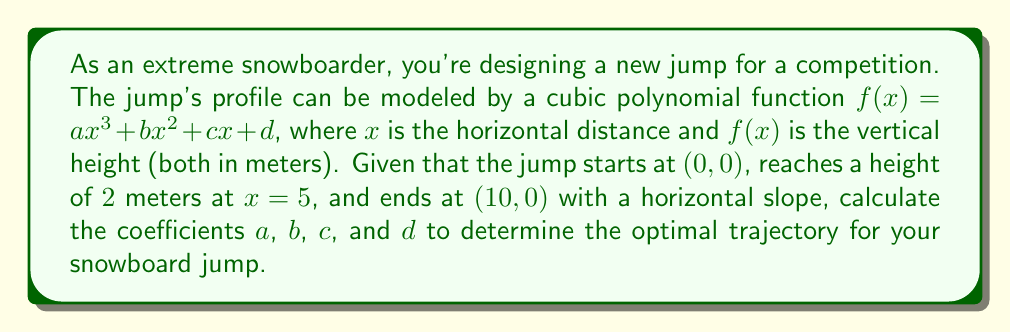Can you solve this math problem? Let's approach this step-by-step:

1) We have four conditions to determine our four unknowns (a, b, c, d):
   i)   $f(0) = 0$  (jump starts at origin)
   ii)  $f(5) = 2$  (reaches 2m height at x = 5)
   iii) $f(10) = 0$ (ends at ground level)
   iv)  $f'(10) = 0$ (horizontal slope at end)

2) From condition i: $f(0) = d = 0$

3) Now our function is $f(x) = ax^3 + bx^2 + cx$

4) From condition ii: $f(5) = a(5^3) + b(5^2) + c(5) = 2$
   $125a + 25b + 5c = 2$ ... (Equation 1)

5) From condition iii: $f(10) = a(10^3) + b(10^2) + c(10) = 0$
   $1000a + 100b + 10c = 0$ ... (Equation 2)

6) For condition iv, we differentiate: $f'(x) = 3ax^2 + 2bx + c$
   Then $f'(10) = 3a(100) + 2b(10) + c = 0$
   $300a + 20b + c = 0$ ... (Equation 3)

7) Now we have a system of three equations with three unknowns:
   125a + 25b + 5c = 2
   1000a + 100b + 10c = 0
   300a + 20b + c = 0

8) Solving this system (using substitution or matrix methods):
   $a = -0.004$
   $b = 0.06$
   $c = 0$

Therefore, the optimal trajectory function is:
$f(x) = -0.004x^3 + 0.06x^2$
Answer: $f(x) = -0.004x^3 + 0.06x^2$ 